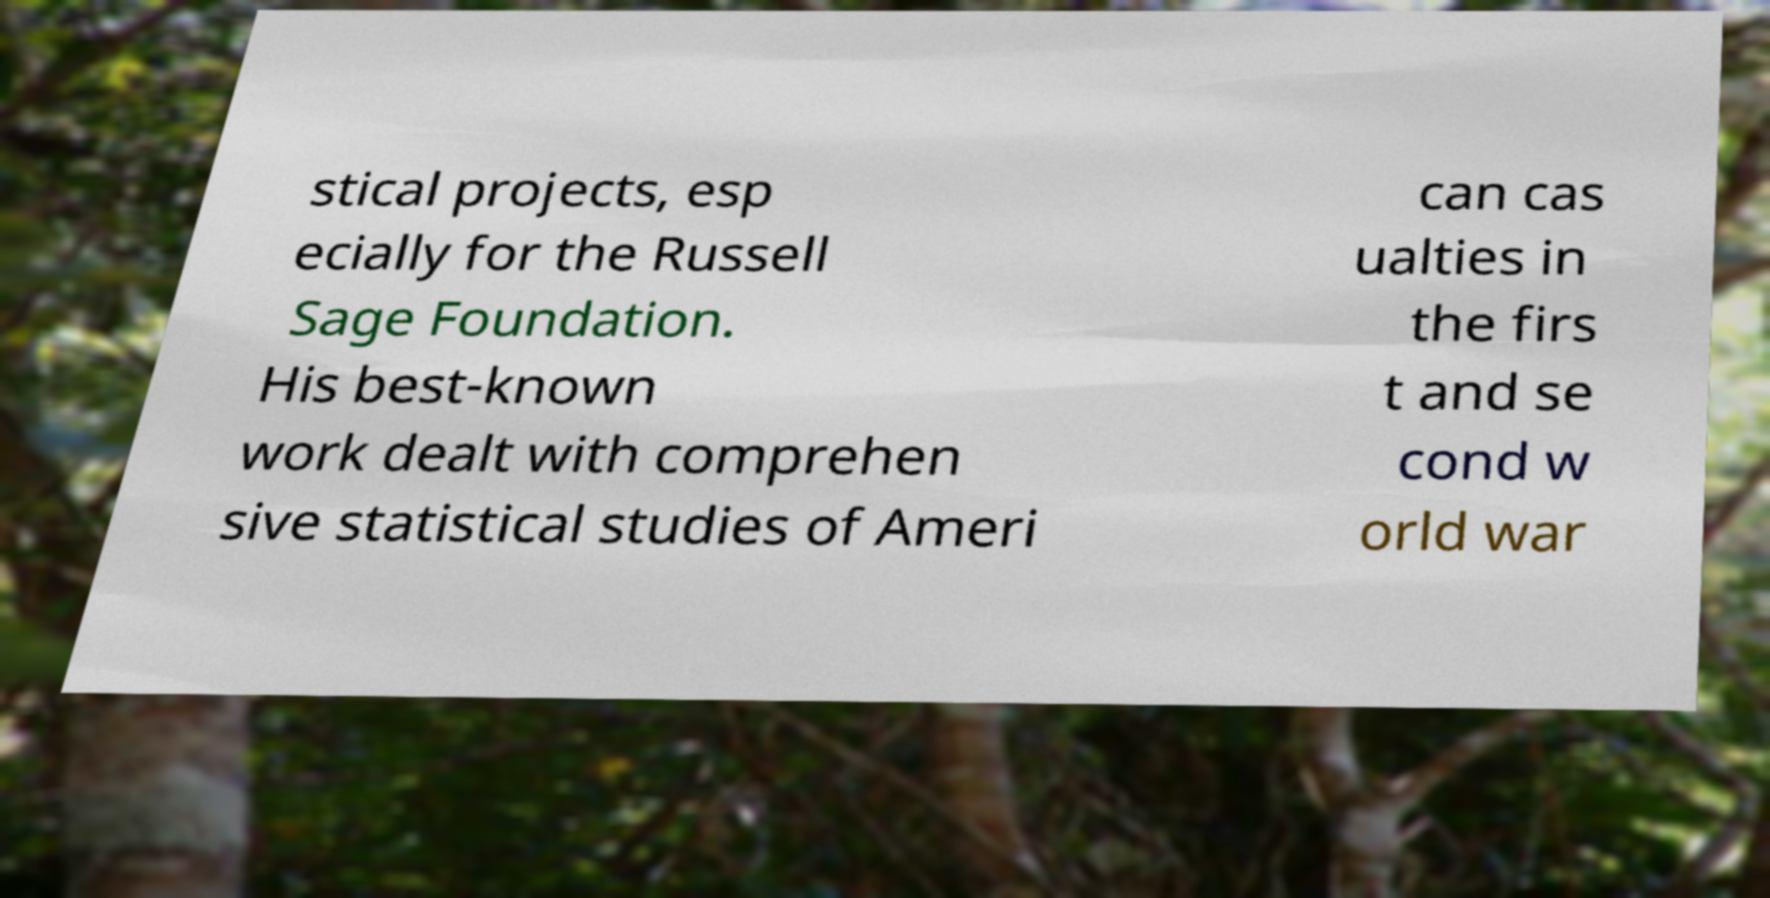Could you assist in decoding the text presented in this image and type it out clearly? stical projects, esp ecially for the Russell Sage Foundation. His best-known work dealt with comprehen sive statistical studies of Ameri can cas ualties in the firs t and se cond w orld war 